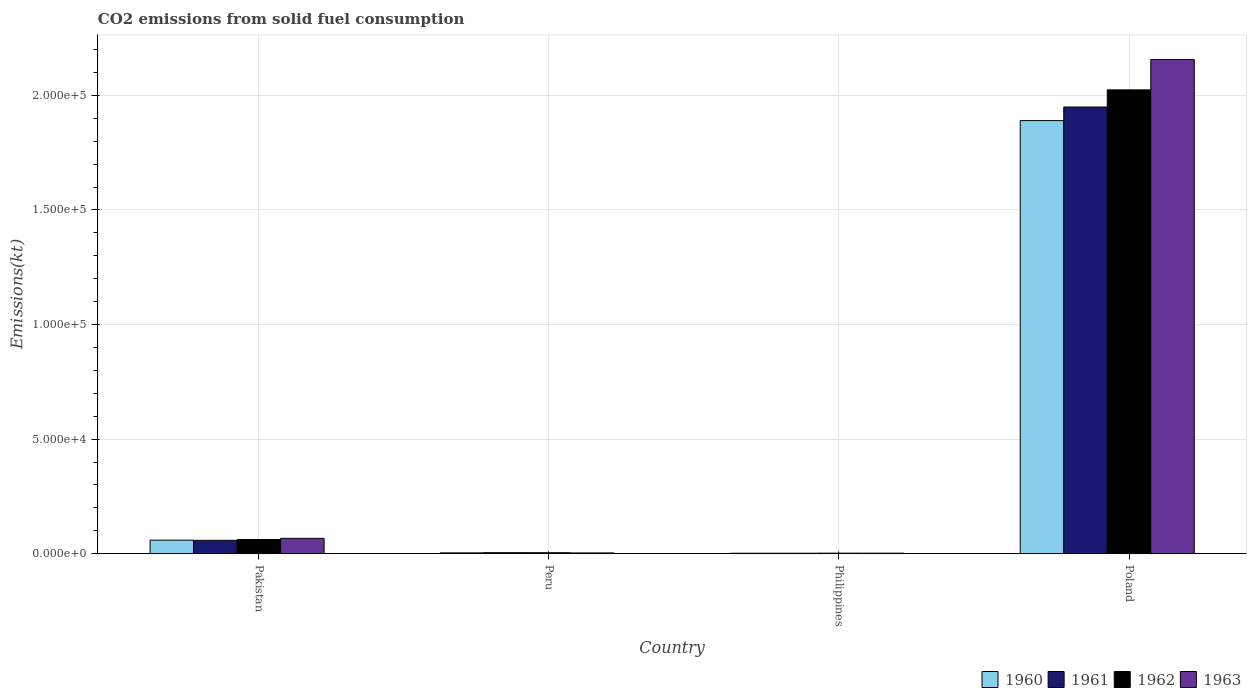How many different coloured bars are there?
Your response must be concise. 4. Are the number of bars per tick equal to the number of legend labels?
Offer a terse response. Yes. How many bars are there on the 1st tick from the left?
Your response must be concise. 4. What is the label of the 1st group of bars from the left?
Give a very brief answer. Pakistan. What is the amount of CO2 emitted in 1961 in Peru?
Ensure brevity in your answer.  432.71. Across all countries, what is the maximum amount of CO2 emitted in 1960?
Keep it short and to the point. 1.89e+05. Across all countries, what is the minimum amount of CO2 emitted in 1960?
Offer a terse response. 179.68. In which country was the amount of CO2 emitted in 1961 maximum?
Your answer should be compact. Poland. What is the total amount of CO2 emitted in 1961 in the graph?
Ensure brevity in your answer.  2.01e+05. What is the difference between the amount of CO2 emitted in 1960 in Pakistan and that in Poland?
Provide a succinct answer. -1.83e+05. What is the difference between the amount of CO2 emitted in 1962 in Pakistan and the amount of CO2 emitted in 1960 in Philippines?
Keep it short and to the point. 6010.21. What is the average amount of CO2 emitted in 1962 per country?
Give a very brief answer. 5.23e+04. What is the difference between the amount of CO2 emitted of/in 1963 and amount of CO2 emitted of/in 1960 in Philippines?
Your answer should be compact. 22. In how many countries, is the amount of CO2 emitted in 1960 greater than 30000 kt?
Your answer should be compact. 1. What is the ratio of the amount of CO2 emitted in 1963 in Peru to that in Philippines?
Give a very brief answer. 1.58. What is the difference between the highest and the second highest amount of CO2 emitted in 1961?
Give a very brief answer. -5372.15. What is the difference between the highest and the lowest amount of CO2 emitted in 1960?
Offer a terse response. 1.89e+05. In how many countries, is the amount of CO2 emitted in 1961 greater than the average amount of CO2 emitted in 1961 taken over all countries?
Offer a terse response. 1. Is the sum of the amount of CO2 emitted in 1961 in Philippines and Poland greater than the maximum amount of CO2 emitted in 1963 across all countries?
Your answer should be very brief. No. Is it the case that in every country, the sum of the amount of CO2 emitted in 1961 and amount of CO2 emitted in 1963 is greater than the sum of amount of CO2 emitted in 1962 and amount of CO2 emitted in 1960?
Offer a terse response. No. What does the 4th bar from the left in Pakistan represents?
Make the answer very short. 1963. How many bars are there?
Provide a short and direct response. 16. Does the graph contain any zero values?
Give a very brief answer. No. Does the graph contain grids?
Keep it short and to the point. Yes. Where does the legend appear in the graph?
Keep it short and to the point. Bottom right. How many legend labels are there?
Your answer should be compact. 4. What is the title of the graph?
Your answer should be compact. CO2 emissions from solid fuel consumption. What is the label or title of the X-axis?
Give a very brief answer. Country. What is the label or title of the Y-axis?
Provide a succinct answer. Emissions(kt). What is the Emissions(kt) of 1960 in Pakistan?
Offer a terse response. 5892.87. What is the Emissions(kt) of 1961 in Pakistan?
Ensure brevity in your answer.  5804.86. What is the Emissions(kt) in 1962 in Pakistan?
Your answer should be very brief. 6189.9. What is the Emissions(kt) of 1963 in Pakistan?
Offer a terse response. 6681.27. What is the Emissions(kt) in 1960 in Peru?
Provide a short and direct response. 352.03. What is the Emissions(kt) in 1961 in Peru?
Your answer should be very brief. 432.71. What is the Emissions(kt) in 1962 in Peru?
Make the answer very short. 407.04. What is the Emissions(kt) in 1963 in Peru?
Your answer should be compact. 319.03. What is the Emissions(kt) in 1960 in Philippines?
Make the answer very short. 179.68. What is the Emissions(kt) of 1961 in Philippines?
Your answer should be very brief. 179.68. What is the Emissions(kt) in 1962 in Philippines?
Offer a terse response. 212.69. What is the Emissions(kt) in 1963 in Philippines?
Make the answer very short. 201.69. What is the Emissions(kt) of 1960 in Poland?
Keep it short and to the point. 1.89e+05. What is the Emissions(kt) of 1961 in Poland?
Your answer should be very brief. 1.95e+05. What is the Emissions(kt) in 1962 in Poland?
Provide a succinct answer. 2.02e+05. What is the Emissions(kt) of 1963 in Poland?
Ensure brevity in your answer.  2.16e+05. Across all countries, what is the maximum Emissions(kt) of 1960?
Your answer should be compact. 1.89e+05. Across all countries, what is the maximum Emissions(kt) in 1961?
Offer a very short reply. 1.95e+05. Across all countries, what is the maximum Emissions(kt) of 1962?
Offer a very short reply. 2.02e+05. Across all countries, what is the maximum Emissions(kt) in 1963?
Make the answer very short. 2.16e+05. Across all countries, what is the minimum Emissions(kt) in 1960?
Make the answer very short. 179.68. Across all countries, what is the minimum Emissions(kt) of 1961?
Your response must be concise. 179.68. Across all countries, what is the minimum Emissions(kt) in 1962?
Provide a short and direct response. 212.69. Across all countries, what is the minimum Emissions(kt) in 1963?
Your response must be concise. 201.69. What is the total Emissions(kt) in 1960 in the graph?
Make the answer very short. 1.95e+05. What is the total Emissions(kt) of 1961 in the graph?
Keep it short and to the point. 2.01e+05. What is the total Emissions(kt) of 1962 in the graph?
Keep it short and to the point. 2.09e+05. What is the total Emissions(kt) of 1963 in the graph?
Make the answer very short. 2.23e+05. What is the difference between the Emissions(kt) in 1960 in Pakistan and that in Peru?
Your response must be concise. 5540.84. What is the difference between the Emissions(kt) of 1961 in Pakistan and that in Peru?
Keep it short and to the point. 5372.15. What is the difference between the Emissions(kt) of 1962 in Pakistan and that in Peru?
Make the answer very short. 5782.86. What is the difference between the Emissions(kt) in 1963 in Pakistan and that in Peru?
Offer a very short reply. 6362.24. What is the difference between the Emissions(kt) in 1960 in Pakistan and that in Philippines?
Provide a succinct answer. 5713.19. What is the difference between the Emissions(kt) in 1961 in Pakistan and that in Philippines?
Give a very brief answer. 5625.18. What is the difference between the Emissions(kt) in 1962 in Pakistan and that in Philippines?
Give a very brief answer. 5977.21. What is the difference between the Emissions(kt) of 1963 in Pakistan and that in Philippines?
Ensure brevity in your answer.  6479.59. What is the difference between the Emissions(kt) in 1960 in Pakistan and that in Poland?
Provide a succinct answer. -1.83e+05. What is the difference between the Emissions(kt) of 1961 in Pakistan and that in Poland?
Your answer should be very brief. -1.89e+05. What is the difference between the Emissions(kt) in 1962 in Pakistan and that in Poland?
Give a very brief answer. -1.96e+05. What is the difference between the Emissions(kt) of 1963 in Pakistan and that in Poland?
Your answer should be compact. -2.09e+05. What is the difference between the Emissions(kt) of 1960 in Peru and that in Philippines?
Offer a terse response. 172.35. What is the difference between the Emissions(kt) of 1961 in Peru and that in Philippines?
Provide a short and direct response. 253.02. What is the difference between the Emissions(kt) in 1962 in Peru and that in Philippines?
Make the answer very short. 194.35. What is the difference between the Emissions(kt) of 1963 in Peru and that in Philippines?
Make the answer very short. 117.34. What is the difference between the Emissions(kt) in 1960 in Peru and that in Poland?
Provide a short and direct response. -1.89e+05. What is the difference between the Emissions(kt) of 1961 in Peru and that in Poland?
Your response must be concise. -1.95e+05. What is the difference between the Emissions(kt) in 1962 in Peru and that in Poland?
Keep it short and to the point. -2.02e+05. What is the difference between the Emissions(kt) in 1963 in Peru and that in Poland?
Your response must be concise. -2.15e+05. What is the difference between the Emissions(kt) of 1960 in Philippines and that in Poland?
Make the answer very short. -1.89e+05. What is the difference between the Emissions(kt) in 1961 in Philippines and that in Poland?
Provide a succinct answer. -1.95e+05. What is the difference between the Emissions(kt) in 1962 in Philippines and that in Poland?
Provide a succinct answer. -2.02e+05. What is the difference between the Emissions(kt) of 1963 in Philippines and that in Poland?
Your answer should be compact. -2.15e+05. What is the difference between the Emissions(kt) of 1960 in Pakistan and the Emissions(kt) of 1961 in Peru?
Provide a succinct answer. 5460.16. What is the difference between the Emissions(kt) of 1960 in Pakistan and the Emissions(kt) of 1962 in Peru?
Your answer should be compact. 5485.83. What is the difference between the Emissions(kt) of 1960 in Pakistan and the Emissions(kt) of 1963 in Peru?
Offer a terse response. 5573.84. What is the difference between the Emissions(kt) in 1961 in Pakistan and the Emissions(kt) in 1962 in Peru?
Offer a very short reply. 5397.82. What is the difference between the Emissions(kt) in 1961 in Pakistan and the Emissions(kt) in 1963 in Peru?
Give a very brief answer. 5485.83. What is the difference between the Emissions(kt) of 1962 in Pakistan and the Emissions(kt) of 1963 in Peru?
Your answer should be very brief. 5870.87. What is the difference between the Emissions(kt) of 1960 in Pakistan and the Emissions(kt) of 1961 in Philippines?
Keep it short and to the point. 5713.19. What is the difference between the Emissions(kt) of 1960 in Pakistan and the Emissions(kt) of 1962 in Philippines?
Your response must be concise. 5680.18. What is the difference between the Emissions(kt) in 1960 in Pakistan and the Emissions(kt) in 1963 in Philippines?
Give a very brief answer. 5691.18. What is the difference between the Emissions(kt) of 1961 in Pakistan and the Emissions(kt) of 1962 in Philippines?
Give a very brief answer. 5592.18. What is the difference between the Emissions(kt) of 1961 in Pakistan and the Emissions(kt) of 1963 in Philippines?
Provide a short and direct response. 5603.18. What is the difference between the Emissions(kt) of 1962 in Pakistan and the Emissions(kt) of 1963 in Philippines?
Your response must be concise. 5988.21. What is the difference between the Emissions(kt) in 1960 in Pakistan and the Emissions(kt) in 1961 in Poland?
Your response must be concise. -1.89e+05. What is the difference between the Emissions(kt) in 1960 in Pakistan and the Emissions(kt) in 1962 in Poland?
Offer a very short reply. -1.97e+05. What is the difference between the Emissions(kt) of 1960 in Pakistan and the Emissions(kt) of 1963 in Poland?
Your response must be concise. -2.10e+05. What is the difference between the Emissions(kt) in 1961 in Pakistan and the Emissions(kt) in 1962 in Poland?
Your answer should be compact. -1.97e+05. What is the difference between the Emissions(kt) of 1961 in Pakistan and the Emissions(kt) of 1963 in Poland?
Ensure brevity in your answer.  -2.10e+05. What is the difference between the Emissions(kt) in 1962 in Pakistan and the Emissions(kt) in 1963 in Poland?
Offer a terse response. -2.09e+05. What is the difference between the Emissions(kt) of 1960 in Peru and the Emissions(kt) of 1961 in Philippines?
Provide a succinct answer. 172.35. What is the difference between the Emissions(kt) of 1960 in Peru and the Emissions(kt) of 1962 in Philippines?
Give a very brief answer. 139.35. What is the difference between the Emissions(kt) in 1960 in Peru and the Emissions(kt) in 1963 in Philippines?
Ensure brevity in your answer.  150.35. What is the difference between the Emissions(kt) of 1961 in Peru and the Emissions(kt) of 1962 in Philippines?
Your answer should be compact. 220.02. What is the difference between the Emissions(kt) in 1961 in Peru and the Emissions(kt) in 1963 in Philippines?
Make the answer very short. 231.02. What is the difference between the Emissions(kt) of 1962 in Peru and the Emissions(kt) of 1963 in Philippines?
Your response must be concise. 205.35. What is the difference between the Emissions(kt) in 1960 in Peru and the Emissions(kt) in 1961 in Poland?
Give a very brief answer. -1.95e+05. What is the difference between the Emissions(kt) of 1960 in Peru and the Emissions(kt) of 1962 in Poland?
Give a very brief answer. -2.02e+05. What is the difference between the Emissions(kt) in 1960 in Peru and the Emissions(kt) in 1963 in Poland?
Give a very brief answer. -2.15e+05. What is the difference between the Emissions(kt) of 1961 in Peru and the Emissions(kt) of 1962 in Poland?
Offer a very short reply. -2.02e+05. What is the difference between the Emissions(kt) of 1961 in Peru and the Emissions(kt) of 1963 in Poland?
Keep it short and to the point. -2.15e+05. What is the difference between the Emissions(kt) of 1962 in Peru and the Emissions(kt) of 1963 in Poland?
Provide a short and direct response. -2.15e+05. What is the difference between the Emissions(kt) of 1960 in Philippines and the Emissions(kt) of 1961 in Poland?
Offer a terse response. -1.95e+05. What is the difference between the Emissions(kt) in 1960 in Philippines and the Emissions(kt) in 1962 in Poland?
Ensure brevity in your answer.  -2.02e+05. What is the difference between the Emissions(kt) of 1960 in Philippines and the Emissions(kt) of 1963 in Poland?
Your answer should be very brief. -2.15e+05. What is the difference between the Emissions(kt) of 1961 in Philippines and the Emissions(kt) of 1962 in Poland?
Provide a succinct answer. -2.02e+05. What is the difference between the Emissions(kt) of 1961 in Philippines and the Emissions(kt) of 1963 in Poland?
Keep it short and to the point. -2.15e+05. What is the difference between the Emissions(kt) of 1962 in Philippines and the Emissions(kt) of 1963 in Poland?
Keep it short and to the point. -2.15e+05. What is the average Emissions(kt) in 1960 per country?
Make the answer very short. 4.89e+04. What is the average Emissions(kt) in 1961 per country?
Offer a very short reply. 5.03e+04. What is the average Emissions(kt) in 1962 per country?
Give a very brief answer. 5.23e+04. What is the average Emissions(kt) in 1963 per country?
Offer a terse response. 5.57e+04. What is the difference between the Emissions(kt) of 1960 and Emissions(kt) of 1961 in Pakistan?
Offer a terse response. 88.01. What is the difference between the Emissions(kt) of 1960 and Emissions(kt) of 1962 in Pakistan?
Offer a terse response. -297.03. What is the difference between the Emissions(kt) in 1960 and Emissions(kt) in 1963 in Pakistan?
Your answer should be very brief. -788.4. What is the difference between the Emissions(kt) in 1961 and Emissions(kt) in 1962 in Pakistan?
Provide a succinct answer. -385.04. What is the difference between the Emissions(kt) in 1961 and Emissions(kt) in 1963 in Pakistan?
Keep it short and to the point. -876.41. What is the difference between the Emissions(kt) of 1962 and Emissions(kt) of 1963 in Pakistan?
Provide a short and direct response. -491.38. What is the difference between the Emissions(kt) in 1960 and Emissions(kt) in 1961 in Peru?
Your answer should be very brief. -80.67. What is the difference between the Emissions(kt) in 1960 and Emissions(kt) in 1962 in Peru?
Your answer should be very brief. -55.01. What is the difference between the Emissions(kt) of 1960 and Emissions(kt) of 1963 in Peru?
Keep it short and to the point. 33. What is the difference between the Emissions(kt) in 1961 and Emissions(kt) in 1962 in Peru?
Make the answer very short. 25.67. What is the difference between the Emissions(kt) in 1961 and Emissions(kt) in 1963 in Peru?
Make the answer very short. 113.68. What is the difference between the Emissions(kt) in 1962 and Emissions(kt) in 1963 in Peru?
Offer a very short reply. 88.01. What is the difference between the Emissions(kt) in 1960 and Emissions(kt) in 1961 in Philippines?
Provide a short and direct response. 0. What is the difference between the Emissions(kt) of 1960 and Emissions(kt) of 1962 in Philippines?
Provide a succinct answer. -33. What is the difference between the Emissions(kt) of 1960 and Emissions(kt) of 1963 in Philippines?
Offer a very short reply. -22. What is the difference between the Emissions(kt) in 1961 and Emissions(kt) in 1962 in Philippines?
Provide a short and direct response. -33. What is the difference between the Emissions(kt) in 1961 and Emissions(kt) in 1963 in Philippines?
Your response must be concise. -22. What is the difference between the Emissions(kt) of 1962 and Emissions(kt) of 1963 in Philippines?
Make the answer very short. 11. What is the difference between the Emissions(kt) in 1960 and Emissions(kt) in 1961 in Poland?
Make the answer very short. -5918.54. What is the difference between the Emissions(kt) in 1960 and Emissions(kt) in 1962 in Poland?
Make the answer very short. -1.34e+04. What is the difference between the Emissions(kt) in 1960 and Emissions(kt) in 1963 in Poland?
Your answer should be compact. -2.66e+04. What is the difference between the Emissions(kt) in 1961 and Emissions(kt) in 1962 in Poland?
Keep it short and to the point. -7484.35. What is the difference between the Emissions(kt) in 1961 and Emissions(kt) in 1963 in Poland?
Your response must be concise. -2.07e+04. What is the difference between the Emissions(kt) in 1962 and Emissions(kt) in 1963 in Poland?
Give a very brief answer. -1.32e+04. What is the ratio of the Emissions(kt) of 1960 in Pakistan to that in Peru?
Your answer should be very brief. 16.74. What is the ratio of the Emissions(kt) in 1961 in Pakistan to that in Peru?
Give a very brief answer. 13.42. What is the ratio of the Emissions(kt) of 1962 in Pakistan to that in Peru?
Offer a terse response. 15.21. What is the ratio of the Emissions(kt) in 1963 in Pakistan to that in Peru?
Provide a short and direct response. 20.94. What is the ratio of the Emissions(kt) of 1960 in Pakistan to that in Philippines?
Ensure brevity in your answer.  32.8. What is the ratio of the Emissions(kt) of 1961 in Pakistan to that in Philippines?
Keep it short and to the point. 32.31. What is the ratio of the Emissions(kt) in 1962 in Pakistan to that in Philippines?
Offer a terse response. 29.1. What is the ratio of the Emissions(kt) in 1963 in Pakistan to that in Philippines?
Offer a terse response. 33.13. What is the ratio of the Emissions(kt) of 1960 in Pakistan to that in Poland?
Your answer should be compact. 0.03. What is the ratio of the Emissions(kt) in 1961 in Pakistan to that in Poland?
Keep it short and to the point. 0.03. What is the ratio of the Emissions(kt) of 1962 in Pakistan to that in Poland?
Provide a short and direct response. 0.03. What is the ratio of the Emissions(kt) of 1963 in Pakistan to that in Poland?
Make the answer very short. 0.03. What is the ratio of the Emissions(kt) of 1960 in Peru to that in Philippines?
Ensure brevity in your answer.  1.96. What is the ratio of the Emissions(kt) of 1961 in Peru to that in Philippines?
Keep it short and to the point. 2.41. What is the ratio of the Emissions(kt) in 1962 in Peru to that in Philippines?
Your answer should be compact. 1.91. What is the ratio of the Emissions(kt) of 1963 in Peru to that in Philippines?
Give a very brief answer. 1.58. What is the ratio of the Emissions(kt) of 1960 in Peru to that in Poland?
Offer a terse response. 0. What is the ratio of the Emissions(kt) of 1961 in Peru to that in Poland?
Your response must be concise. 0. What is the ratio of the Emissions(kt) in 1962 in Peru to that in Poland?
Provide a succinct answer. 0. What is the ratio of the Emissions(kt) of 1963 in Peru to that in Poland?
Ensure brevity in your answer.  0. What is the ratio of the Emissions(kt) of 1960 in Philippines to that in Poland?
Keep it short and to the point. 0. What is the ratio of the Emissions(kt) of 1961 in Philippines to that in Poland?
Your answer should be very brief. 0. What is the ratio of the Emissions(kt) of 1962 in Philippines to that in Poland?
Offer a very short reply. 0. What is the ratio of the Emissions(kt) of 1963 in Philippines to that in Poland?
Ensure brevity in your answer.  0. What is the difference between the highest and the second highest Emissions(kt) in 1960?
Offer a very short reply. 1.83e+05. What is the difference between the highest and the second highest Emissions(kt) of 1961?
Keep it short and to the point. 1.89e+05. What is the difference between the highest and the second highest Emissions(kt) in 1962?
Offer a terse response. 1.96e+05. What is the difference between the highest and the second highest Emissions(kt) of 1963?
Provide a succinct answer. 2.09e+05. What is the difference between the highest and the lowest Emissions(kt) in 1960?
Give a very brief answer. 1.89e+05. What is the difference between the highest and the lowest Emissions(kt) in 1961?
Provide a succinct answer. 1.95e+05. What is the difference between the highest and the lowest Emissions(kt) in 1962?
Offer a very short reply. 2.02e+05. What is the difference between the highest and the lowest Emissions(kt) in 1963?
Provide a short and direct response. 2.15e+05. 